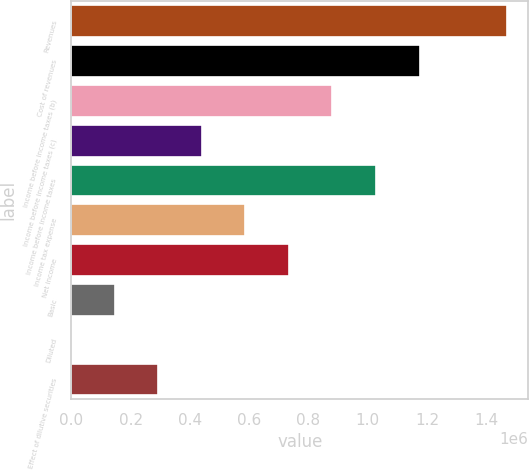Convert chart. <chart><loc_0><loc_0><loc_500><loc_500><bar_chart><fcel>Revenues<fcel>Cost of revenues<fcel>Income before income taxes (b)<fcel>Income before income taxes (c)<fcel>Income before income taxes<fcel>Income tax expense<fcel>Net income<fcel>Basic<fcel>Diluted<fcel>Effect of dilutive securities<nl><fcel>1.46778e+06<fcel>1.17422e+06<fcel>880668<fcel>440334<fcel>1.02745e+06<fcel>587112<fcel>733890<fcel>146778<fcel>0.3<fcel>293556<nl></chart> 